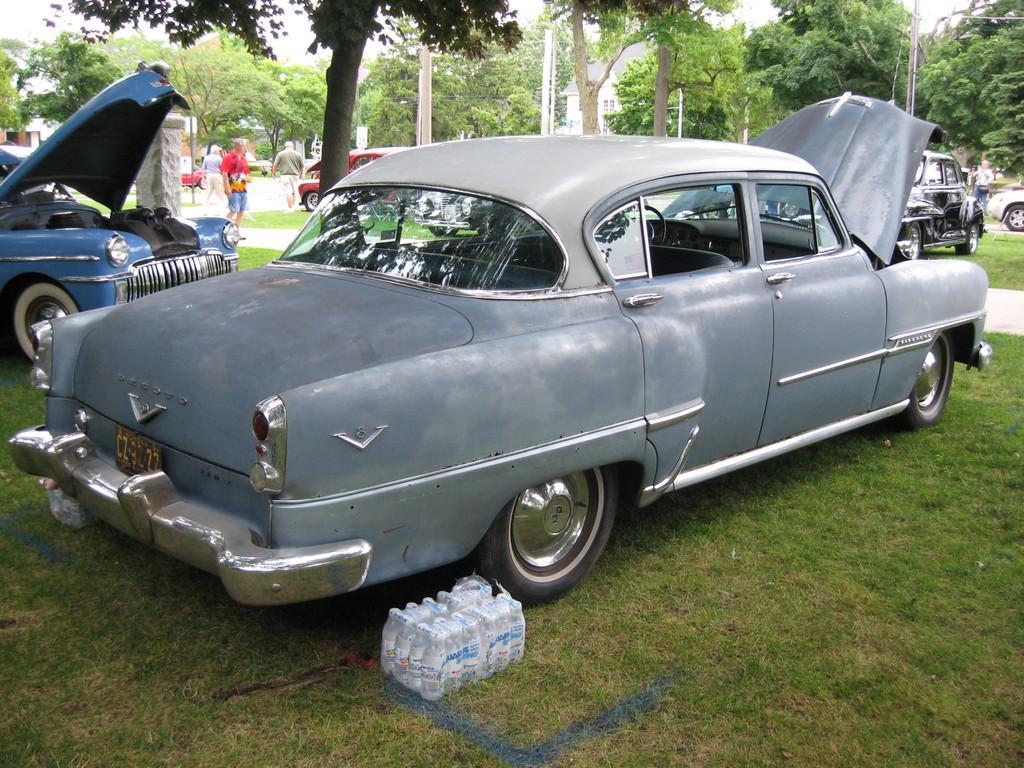How would you summarize this image in a sentence or two? It is a car in grey color, at the bottom there are packed bottles. There are trees at the backside of an image. 